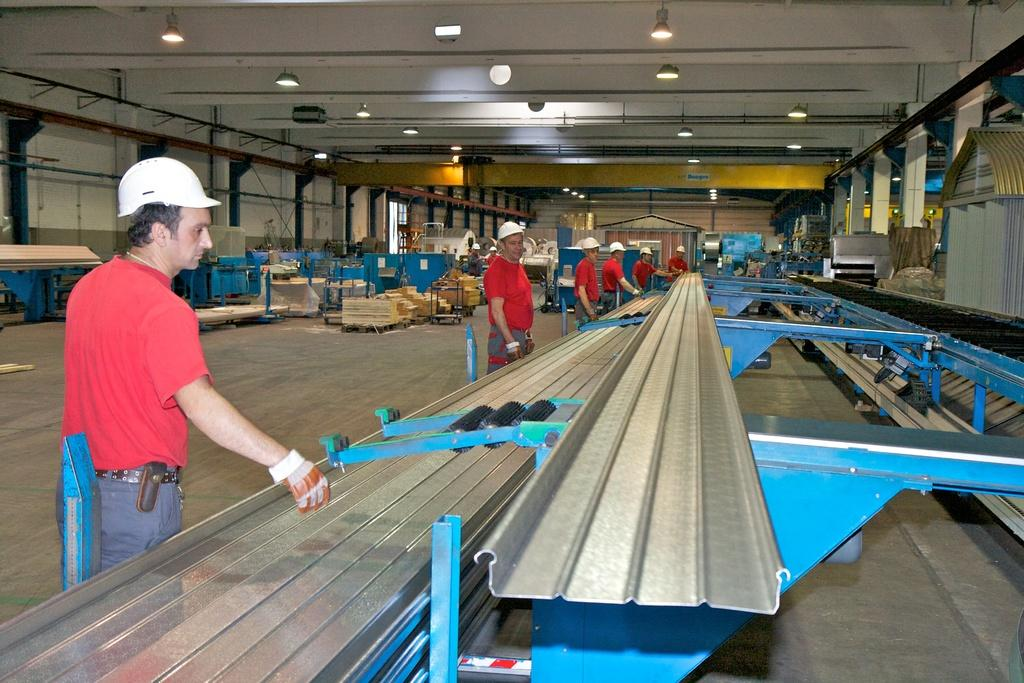What can be seen in the image? There are machines and persons in the image. What are the persons wearing? The persons are wearing red t-shirts and caps. What is the structure of the area in the image? There is a roof with lights, and a floor in the image. Can you see the brother of the person wearing the red t-shirt in the image? There is no mention of a brother in the image, so we cannot determine if they are present or not. 